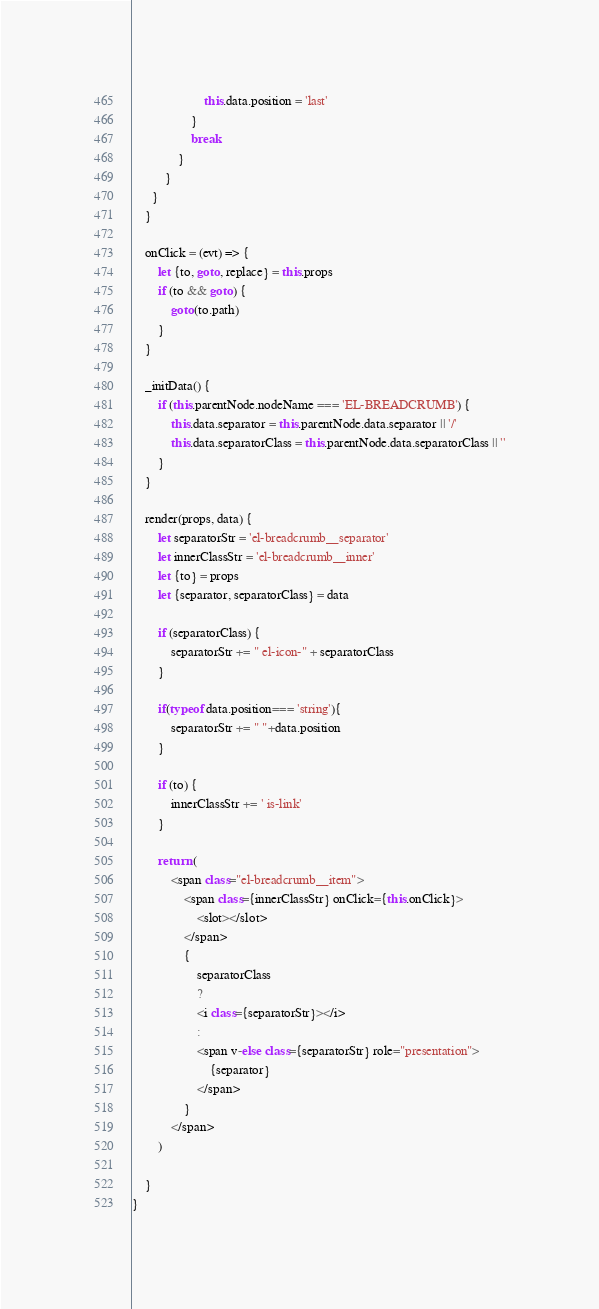<code> <loc_0><loc_0><loc_500><loc_500><_JavaScript_>                      this.data.position = 'last'
                  }
                  break
              }
          }
      }
    }

    onClick = (evt) => {
        let {to, goto, replace} = this.props
        if (to && goto) { 
            goto(to.path)
        }
    }
    
    _initData() {
        if (this.parentNode.nodeName === 'EL-BREADCRUMB') {
            this.data.separator = this.parentNode.data.separator || '/'
            this.data.separatorClass = this.parentNode.data.separatorClass || ''
        }
    }

    render(props, data) {
        let separatorStr = 'el-breadcrumb__separator'
        let innerClassStr = 'el-breadcrumb__inner'
        let {to} = props
        let {separator, separatorClass} = data

        if (separatorClass) {
            separatorStr += " el-icon-" + separatorClass
        }

        if(typeof data.position=== 'string'){
            separatorStr += " "+data.position
        }
        
        if (to) {
            innerClassStr += ' is-link'
        }
        
        return (
            <span class="el-breadcrumb__item">
                <span class={innerClassStr} onClick={this.onClick}>
                    <slot></slot>
                </span>
                {
                    separatorClass
                    ? 
                    <i class={separatorStr}></i>
                    : 
                    <span v-else class={separatorStr} role="presentation">
                        {separator}
                    </span>
                }
            </span>
        )
      
    }
}</code> 